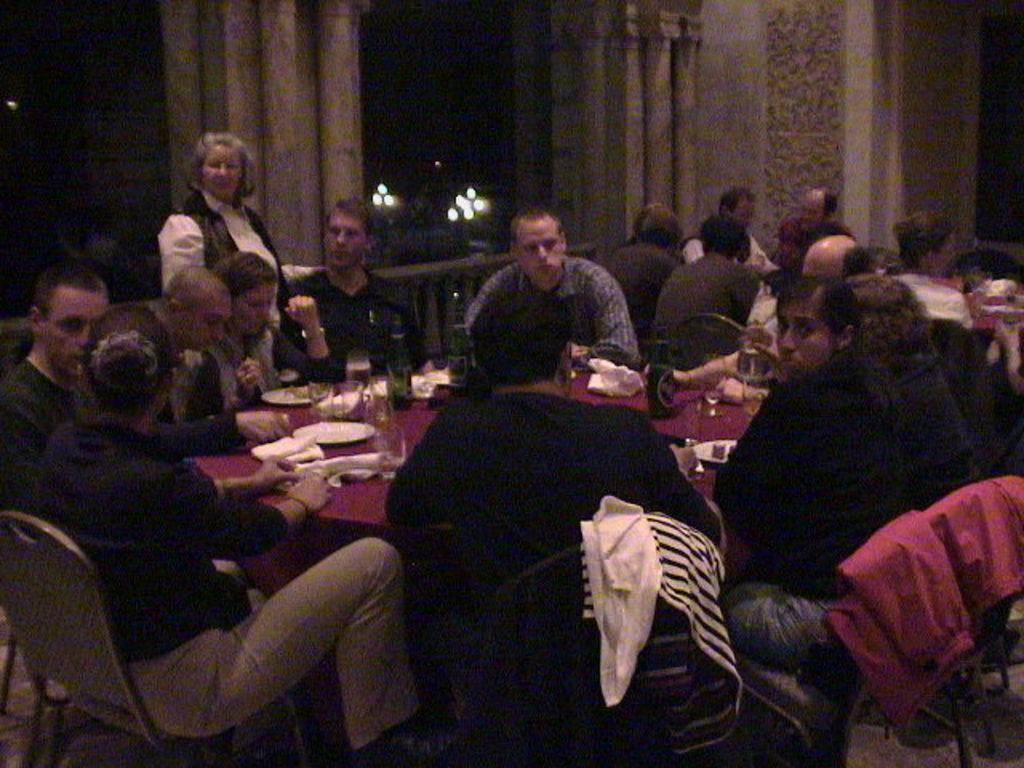Describe this image in one or two sentences. People are seated on the chairs. There is a table at the center on which there are glasses, bottles and plates. A woman is standing. There are curtains and fence. There are lights at the back. 